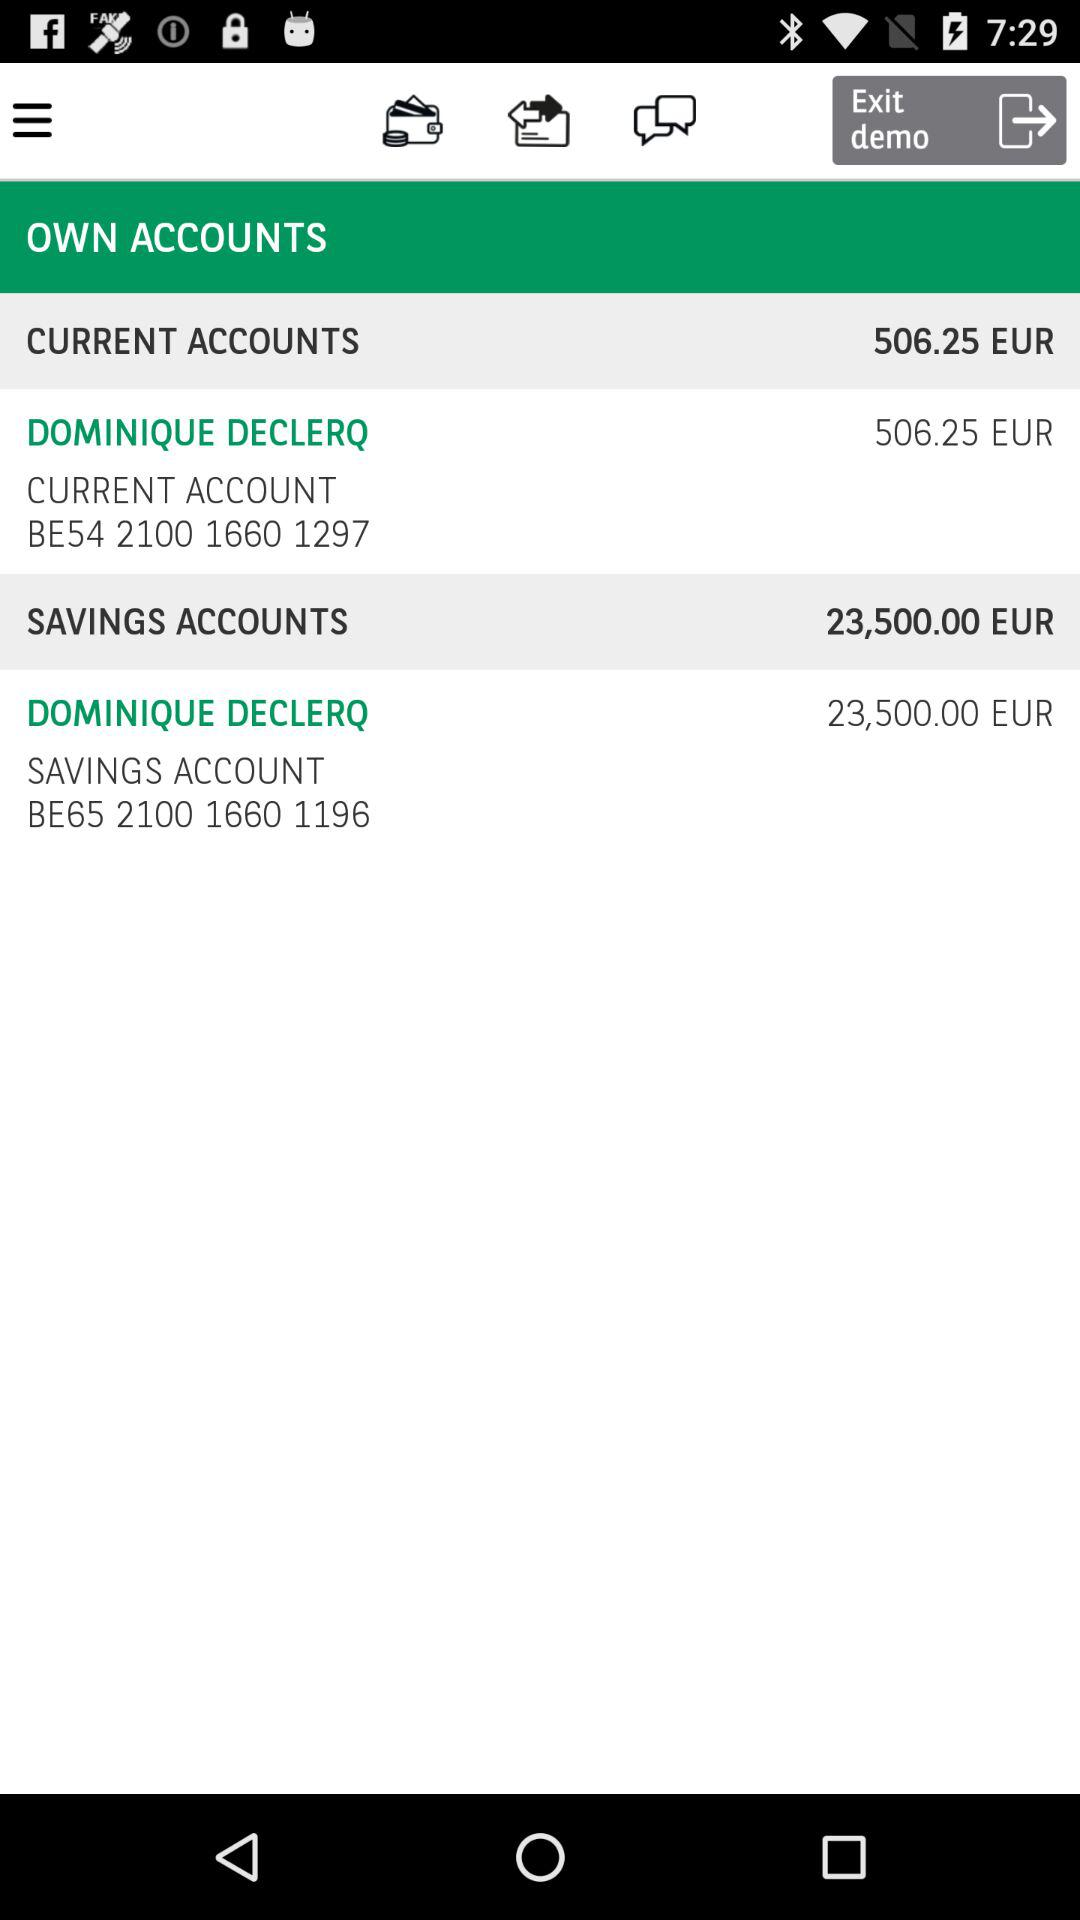What is the balance in the current accounts? The balance is 506.25 euros. 